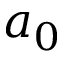<formula> <loc_0><loc_0><loc_500><loc_500>a _ { 0 }</formula> 